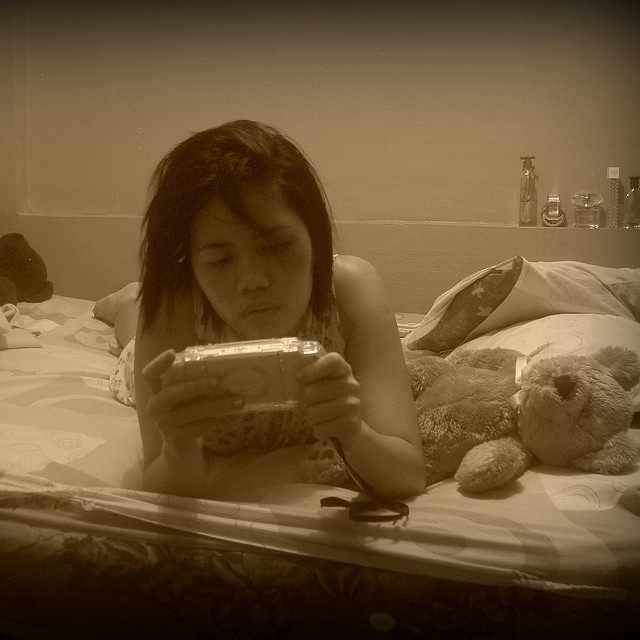Describe the objects in this image and their specific colors. I can see bed in black, olive, tan, and maroon tones, people in black, maroon, and olive tones, teddy bear in black, olive, maroon, and tan tones, bottle in black, olive, and tan tones, and bottle in black, olive, and tan tones in this image. 